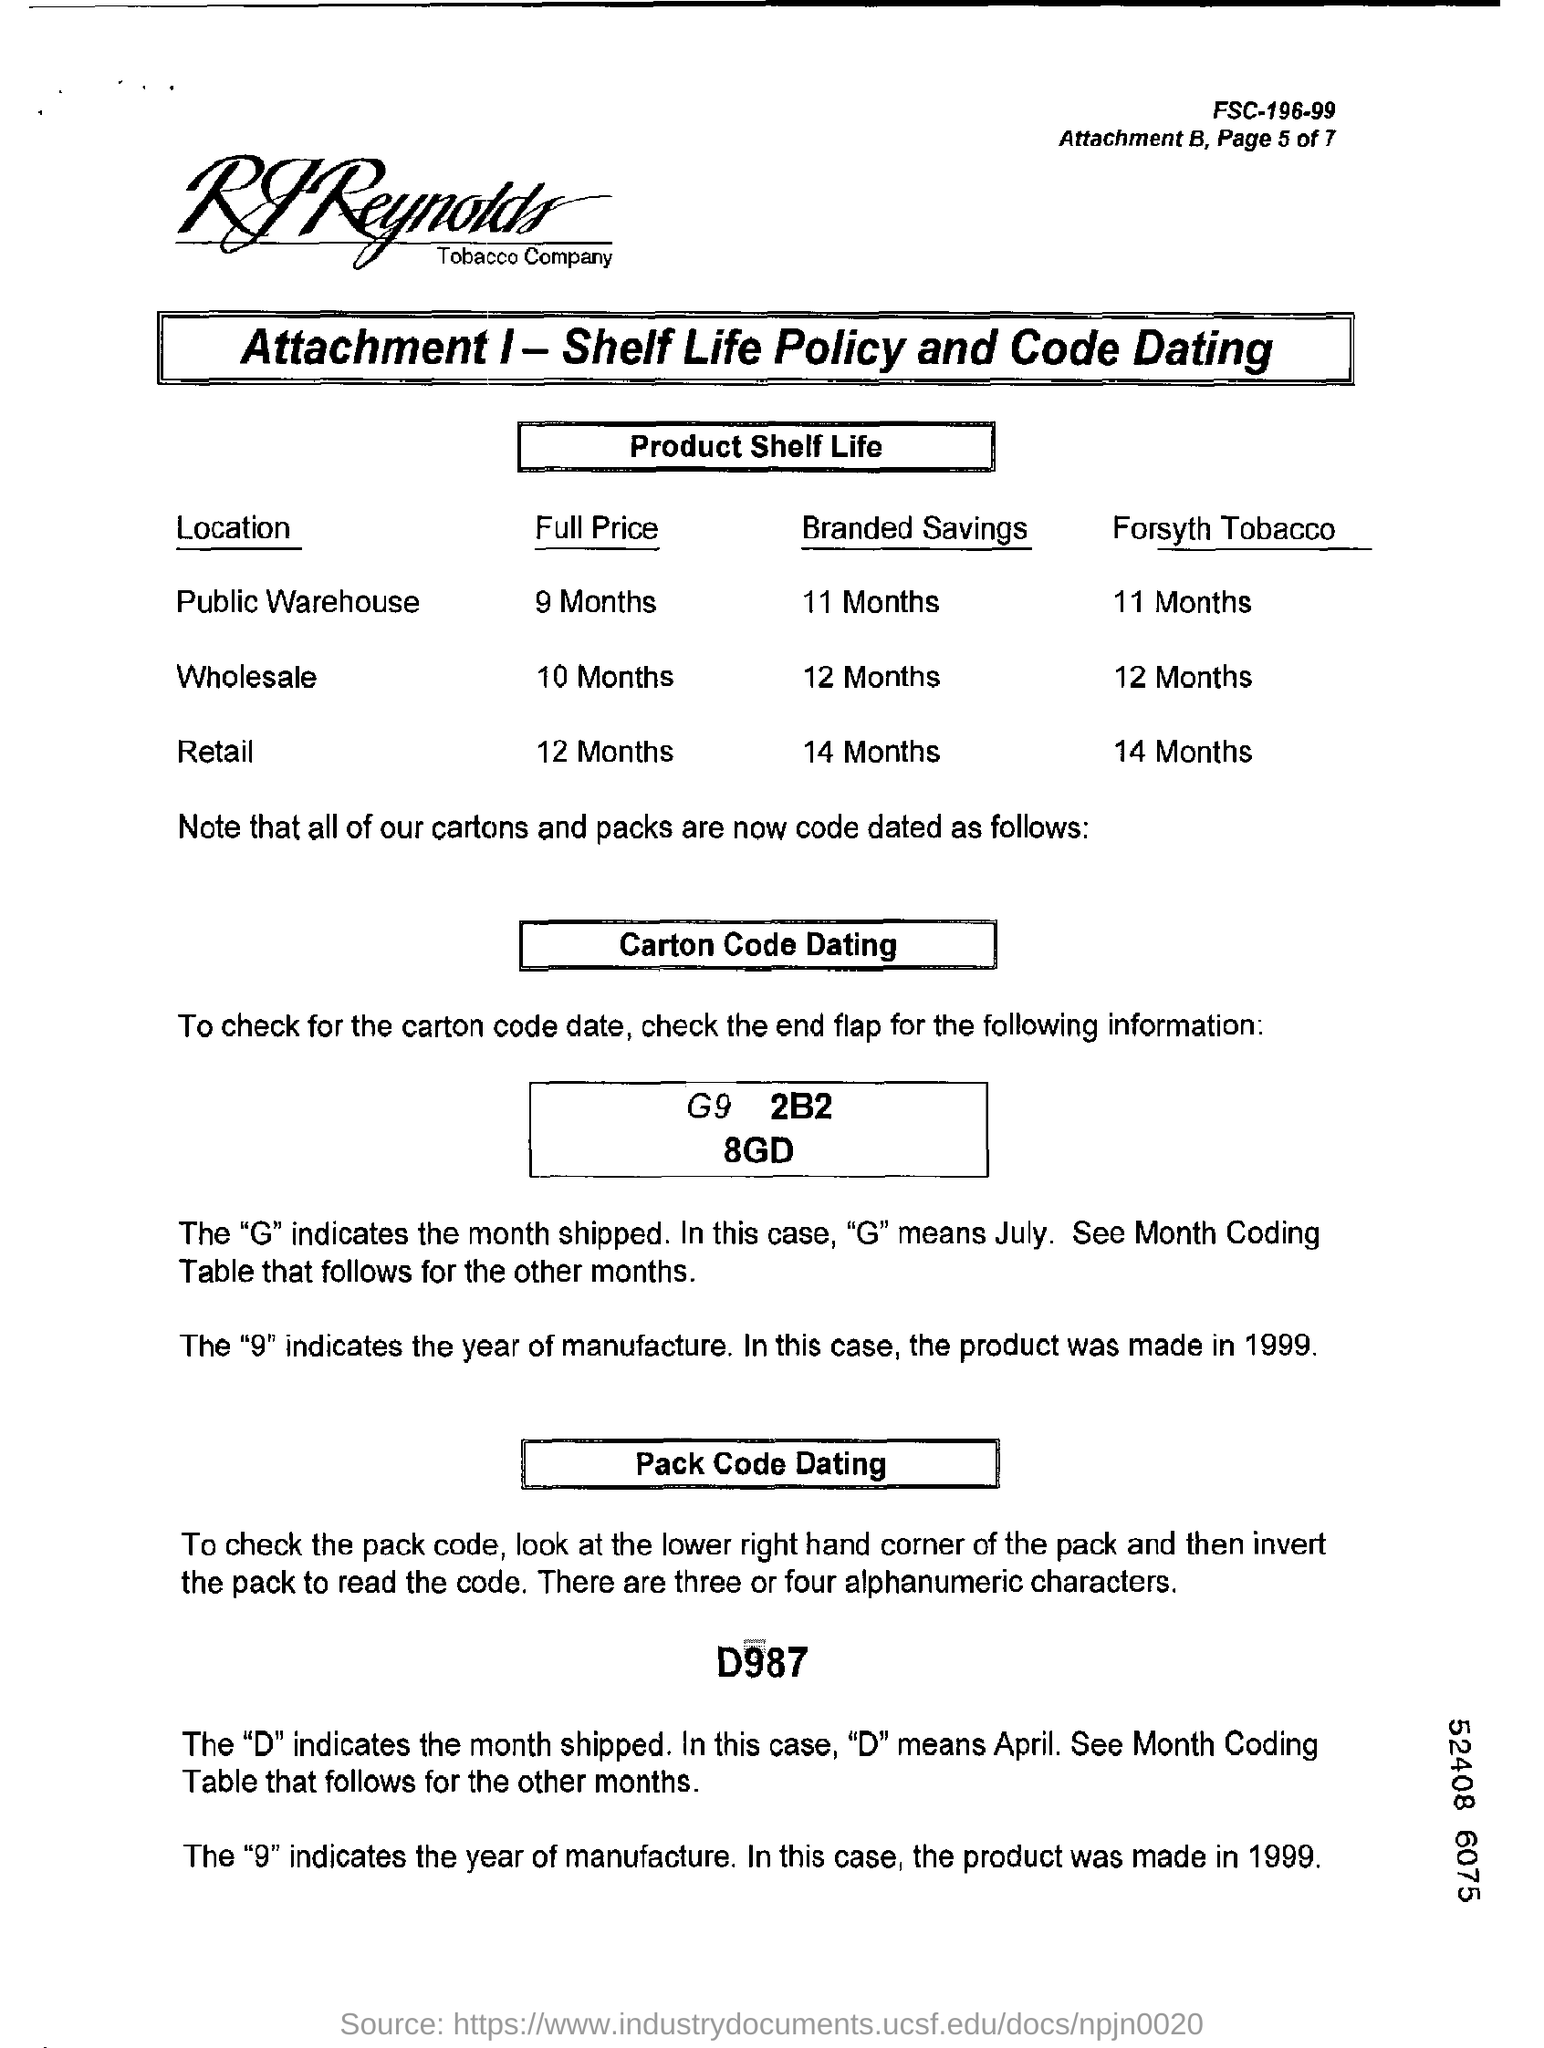Give some essential details in this illustration. The full price of wholesale spans over 10 months. The symbol "9" in D987 indicates the year of manufacture. In the document with the number "D987," the letter "D" is used to indicate the month in which the item was shipped. The full price of retail is 12 months. 